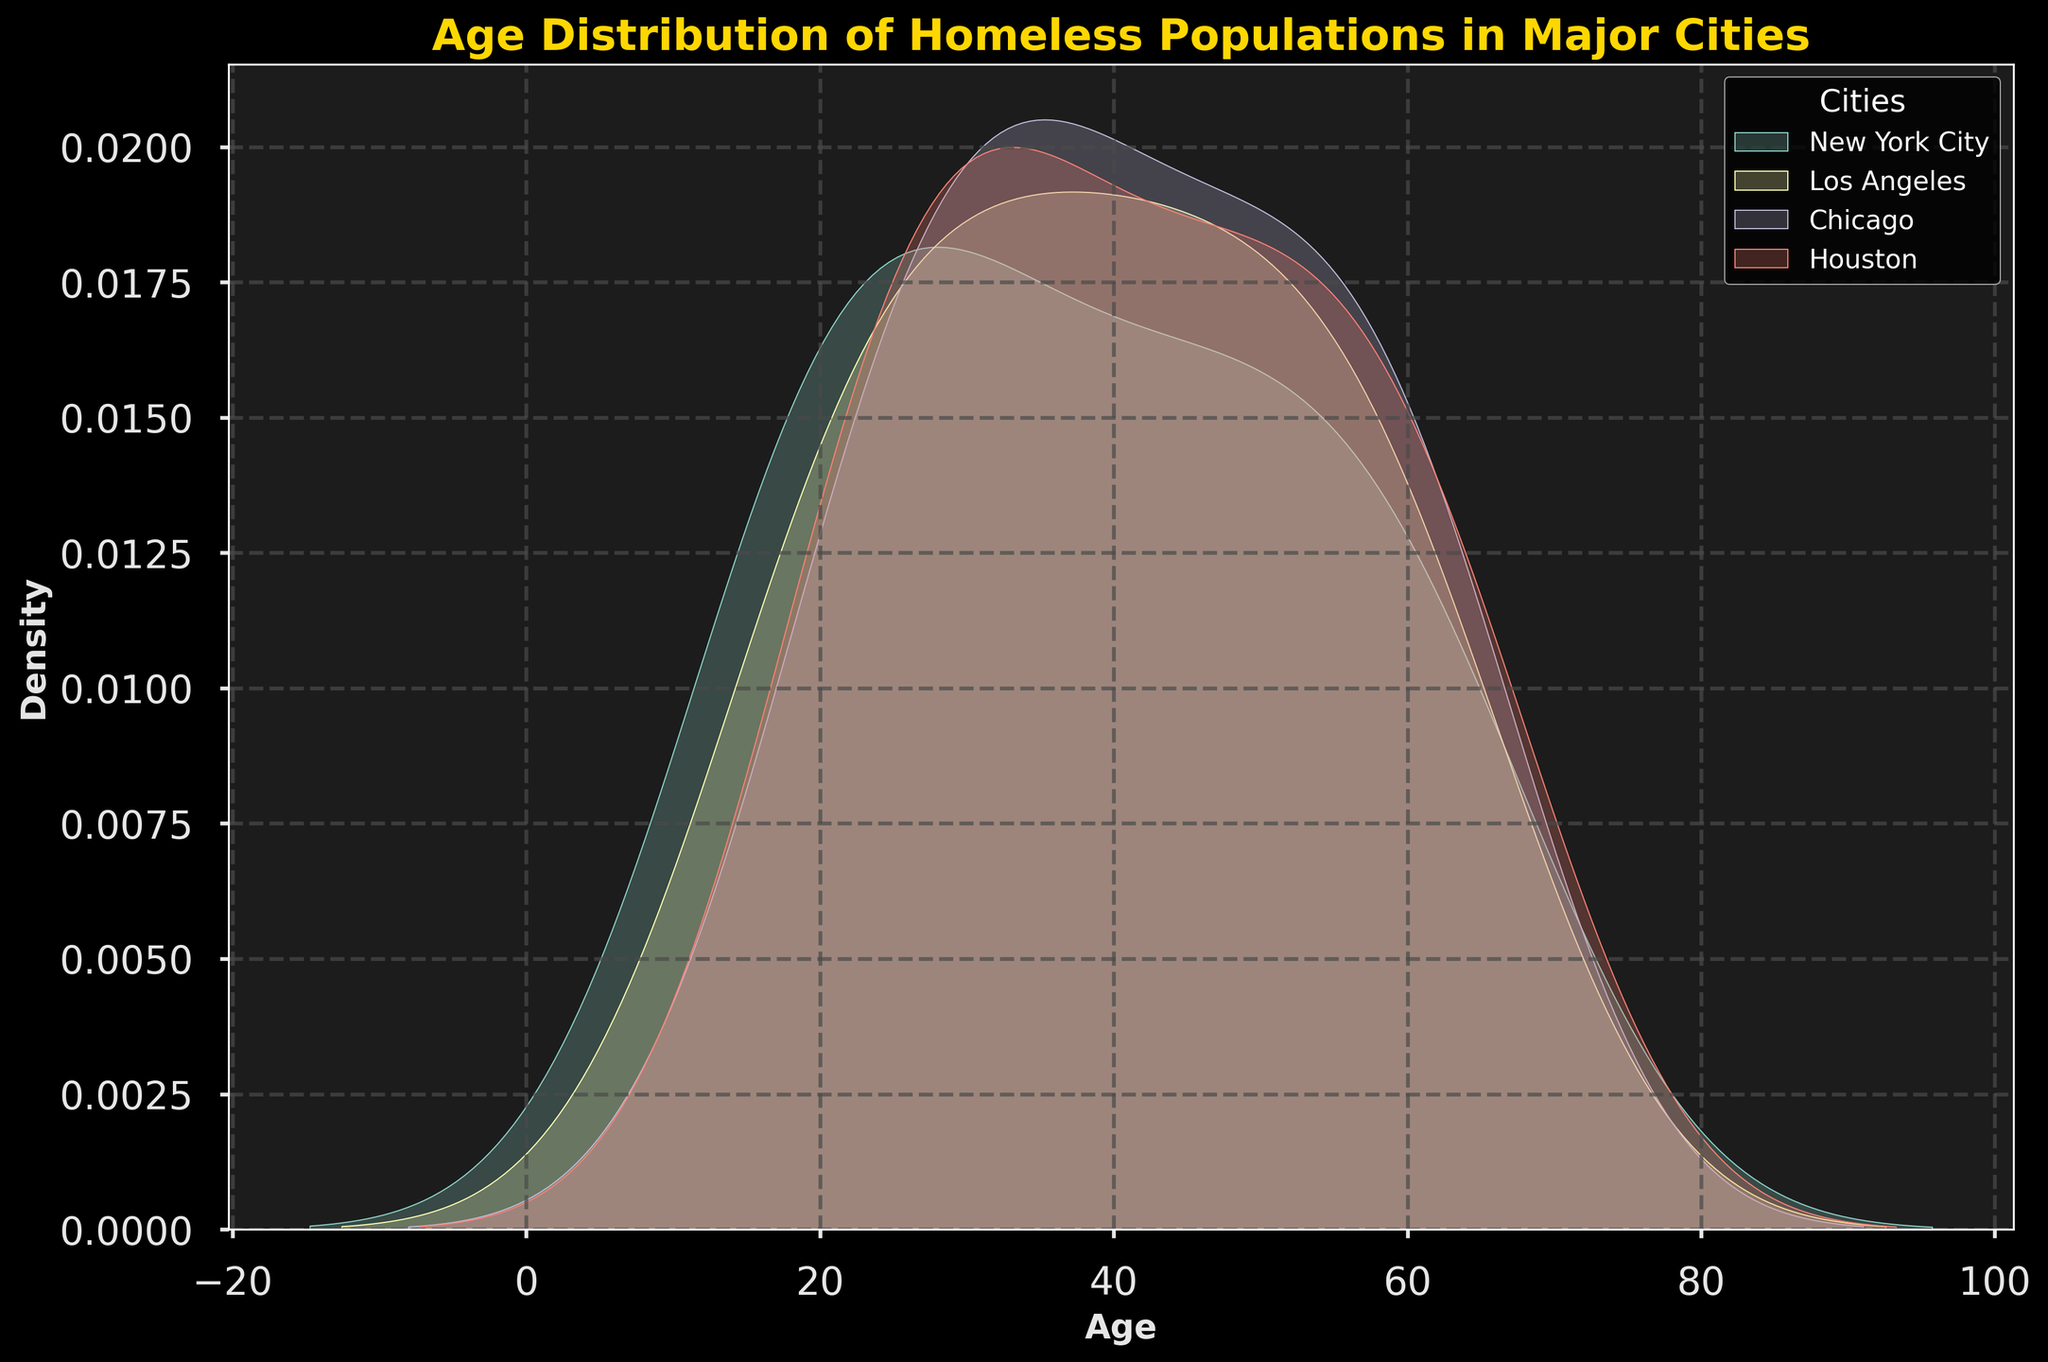What is the title of the plot? The title of the plot is typically located at the top of the figure in larger and bolder text. By observing the top of the figure, we see the title "Age Distribution of Homeless Populations in Major Cities".
Answer: Age Distribution of Homeless Populations in Major Cities What is the x-axis label? The x-axis label is found along the horizontal axis of the plot. It denotes what is being measured on this axis. In this plot, the x-axis label is "Age".
Answer: Age Which city shows the highest density peak in the plot? To determine the city with the highest density peak, examine the plot lines closely. The highest peak represents the city with the most concentrated population within a specific age range.
Answer: New York City How does the age distribution in Chicago compare to that in Los Angeles? By comparing the density lines for Chicago and Los Angeles, we can see that both follow somewhat similar distributions but might peak differently. Observe the nature of the peaks and their broadness to make a comparison.
Answer: Similar distributions Which city has the broadest age distribution among homeless populations? The city with the broadest distribution will have a wide spread without sharp peaks. By looking at the spread of the density lines, we can determine that Houston has the broadest distribution.
Answer: Houston Are there any cities that have overlapping age ranges in the plot? Overlapping age ranges are indicated by density plots that overlap across certain age ranges. By examining the plot, New York City and Los Angeles have overlapping age ranges.
Answer: Yes What does the density peak of 25-30 years in Los Angeles suggest about the homeless population there? A peak in the density plot suggests a higher concentration of the population within that age range. For Los Angeles, a peak at 25-30 years indicates many homeless individuals fall within that age range.
Answer: Higher concentration of age 25-30 Is there a noticeable age range difference in the age distributions between New York City and Houston? By observing the plot, we can see that New York City has a peak around younger ages (16-25), whereas Houston has a broader peak covering various age ranges.
Answer: Yes Which city has the least density at age 60? To find the city with the least density, identify the lowest point on the plot at age 60 across all cities. From the plot, we see that Chicago has the lowest density at age 60.
Answer: Chicago Based on the plot, do you think age-specific programs should be uniform across all cities? The differing density peaks and age distributions suggest that targeted interventions are necessary for each city rather than a one-size-fits-all approach, as each city has unique age-related needs.
Answer: No 